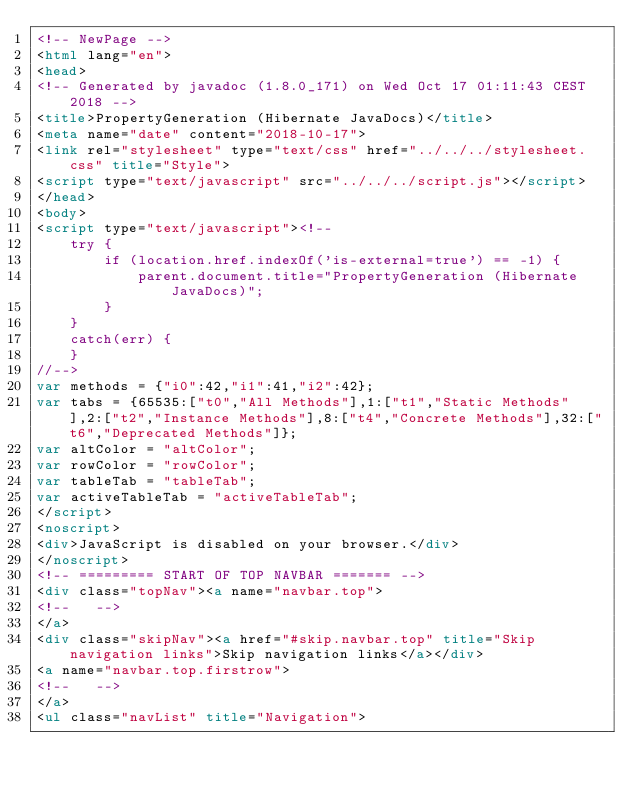Convert code to text. <code><loc_0><loc_0><loc_500><loc_500><_HTML_><!-- NewPage -->
<html lang="en">
<head>
<!-- Generated by javadoc (1.8.0_171) on Wed Oct 17 01:11:43 CEST 2018 -->
<title>PropertyGeneration (Hibernate JavaDocs)</title>
<meta name="date" content="2018-10-17">
<link rel="stylesheet" type="text/css" href="../../../stylesheet.css" title="Style">
<script type="text/javascript" src="../../../script.js"></script>
</head>
<body>
<script type="text/javascript"><!--
    try {
        if (location.href.indexOf('is-external=true') == -1) {
            parent.document.title="PropertyGeneration (Hibernate JavaDocs)";
        }
    }
    catch(err) {
    }
//-->
var methods = {"i0":42,"i1":41,"i2":42};
var tabs = {65535:["t0","All Methods"],1:["t1","Static Methods"],2:["t2","Instance Methods"],8:["t4","Concrete Methods"],32:["t6","Deprecated Methods"]};
var altColor = "altColor";
var rowColor = "rowColor";
var tableTab = "tableTab";
var activeTableTab = "activeTableTab";
</script>
<noscript>
<div>JavaScript is disabled on your browser.</div>
</noscript>
<!-- ========= START OF TOP NAVBAR ======= -->
<div class="topNav"><a name="navbar.top">
<!--   -->
</a>
<div class="skipNav"><a href="#skip.navbar.top" title="Skip navigation links">Skip navigation links</a></div>
<a name="navbar.top.firstrow">
<!--   -->
</a>
<ul class="navList" title="Navigation"></code> 